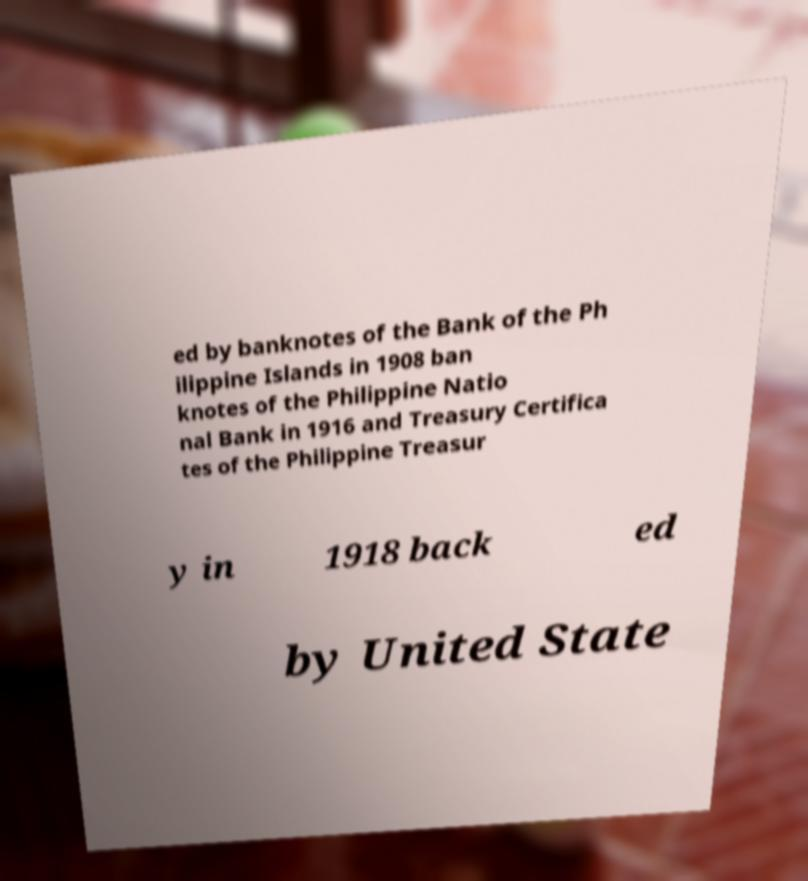Please identify and transcribe the text found in this image. ed by banknotes of the Bank of the Ph ilippine Islands in 1908 ban knotes of the Philippine Natio nal Bank in 1916 and Treasury Certifica tes of the Philippine Treasur y in 1918 back ed by United State 